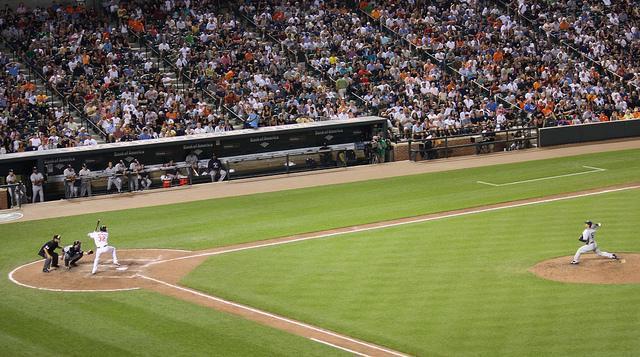The man wearing what color of shirt is responsible for rendering decisions on judgment calls?
From the following set of four choices, select the accurate answer to respond to the question.
Options: Red, white, blue, black. Black. 